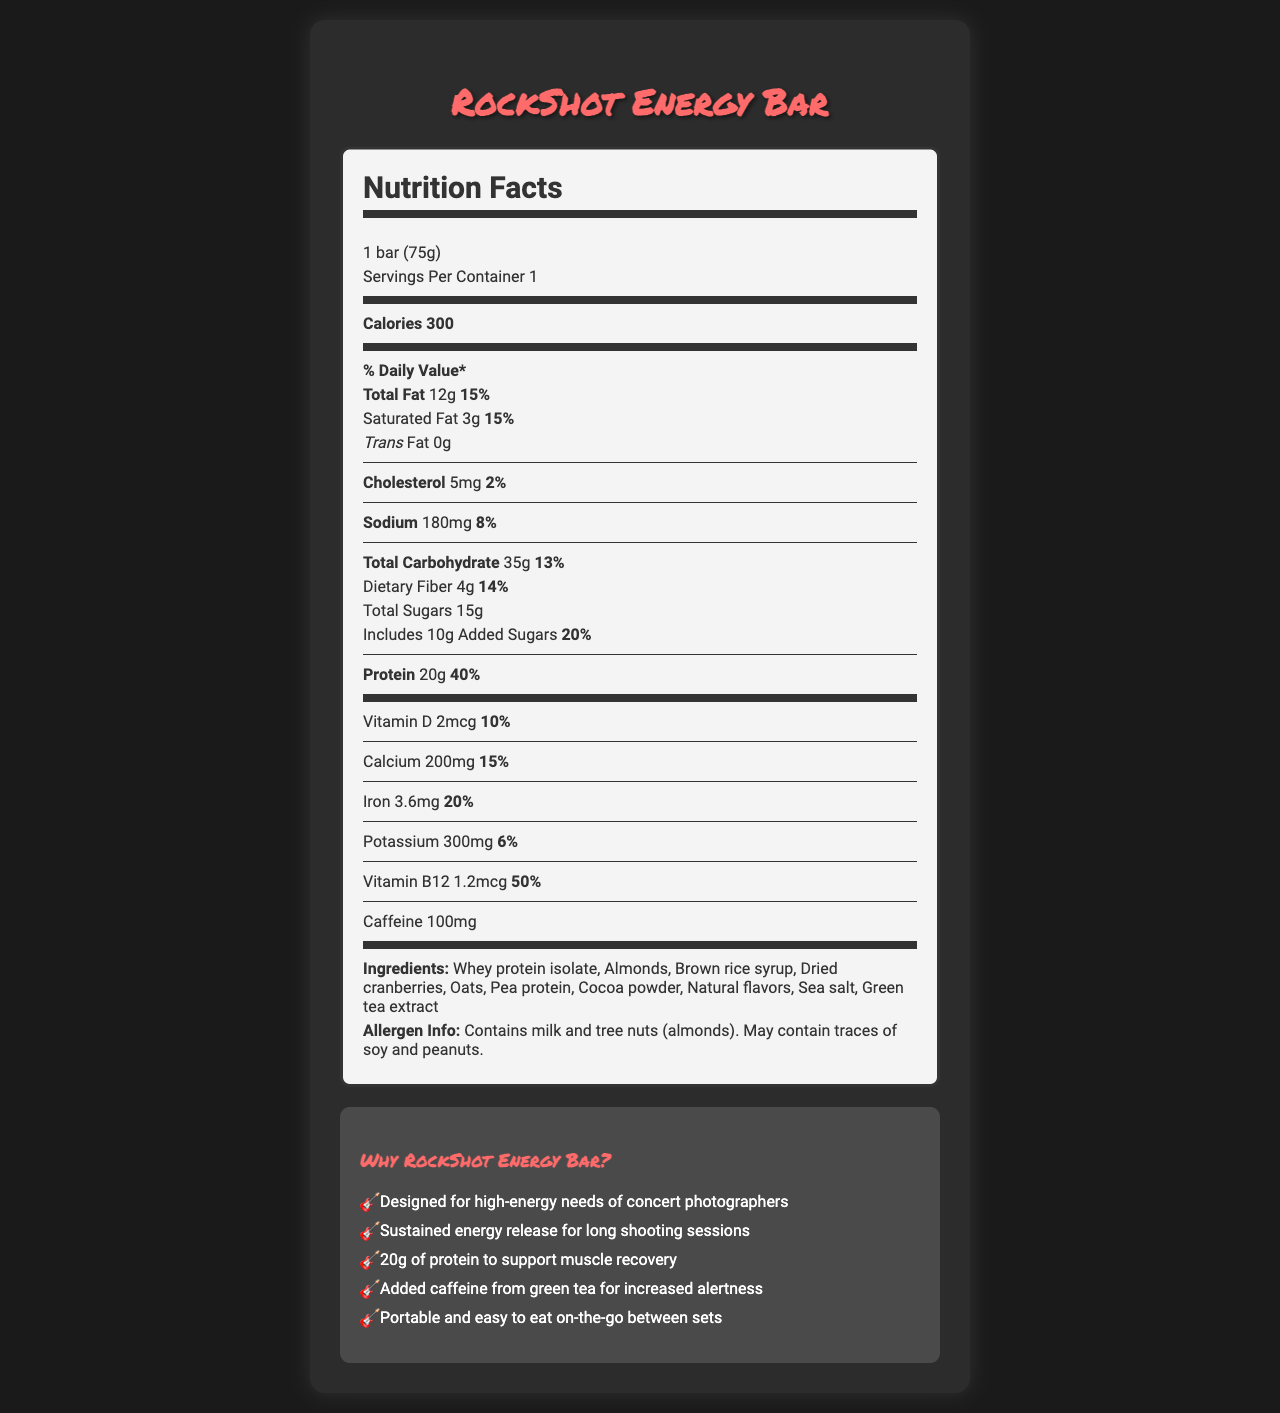What is the serving size of the RockShot Energy Bar? The serving size is clearly listed as "1 bar (75g)" on the nutrition label.
Answer: 1 bar (75g) How much protein does the RockShot Energy Bar contain? The nutrition label indicates that there are 20g of protein per serving.
Answer: 20g What percentage of the daily value of calories does the RockShot Energy Bar provide? The document provides the calorie content (300 calories) but does not indicate the percentage of daily value for calories.
Answer: Not enough information List three main ingredients in the RockShot Energy Bar. The ingredients list includes these as the first three items.
Answer: Whey protein isolate, Almonds, Brown rice syrup How much Vitamin B12 is there in the RockShot Energy Bar? The nutrient section specifies that there is 1.2mcg of Vitamin B12.
Answer: 1.2mcg What are the total carbohydrates in one bar of the RockShot Energy Bar? According to the nutrition label, there are 35g of total carbohydrates per serving.
Answer: 35g What is the amount of caffeine in the RockShot Energy Bar? The caffeine content is listed directly on the nutrition label as 100mg.
Answer: 100mg What allergens are contained in the RockShot Energy Bar? The allergen information states these specific allergens.
Answer: Contains milk and tree nuts (almonds). May contain traces of soy and peanuts. Which nutrient has the highest percentage of daily value? A. Calcium B. Vitamin D C. Protein D. Vitamin B12 Vitamin B12 has the highest daily value percentage at 50%, higher than all other listed nutrients.
Answer: D. Vitamin B12 What claims are made about the RockShot Energy Bar? A. High in protein B. Low in sugar C. Contains green tea extract D. Designed for concert photographers The claims include high protein content, containing green tea extract, and being designed for concert photographers. It does not claim low sugar.
Answer: A, C, D Does the RockShot Energy Bar contain any trans fat? The nutrition label indicates 0g of trans fat.
Answer: No Summarize the main idea of the document. The document presents detailed nutritional information and highlights the bar's benefits, specifically targeting concert photographers.
Answer: The RockShot Energy Bar is a high-energy protein bar designed for concert photographers. It provides key nutritional information, including calories, fats, carbohydrates, protein, and vitamins. It also lists ingredients, allergens, and several marketing claims, emphasizing its suitability for high-energy activities and long shooting sessions. Does this energy bar contain any peanuts? The allergen information indicates it may contain traces of peanuts, but it does not definitively state whether peanuts are an ingredient.
Answer: Cannot be determined 